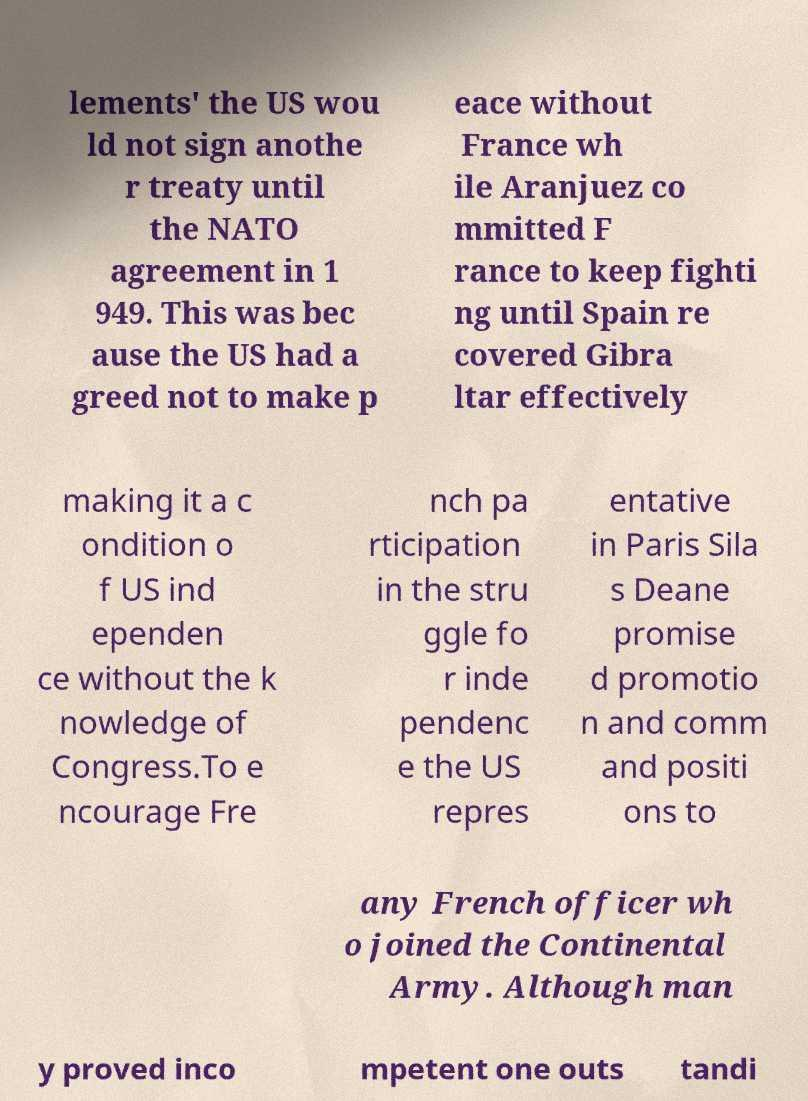Can you accurately transcribe the text from the provided image for me? lements' the US wou ld not sign anothe r treaty until the NATO agreement in 1 949. This was bec ause the US had a greed not to make p eace without France wh ile Aranjuez co mmitted F rance to keep fighti ng until Spain re covered Gibra ltar effectively making it a c ondition o f US ind ependen ce without the k nowledge of Congress.To e ncourage Fre nch pa rticipation in the stru ggle fo r inde pendenc e the US repres entative in Paris Sila s Deane promise d promotio n and comm and positi ons to any French officer wh o joined the Continental Army. Although man y proved inco mpetent one outs tandi 